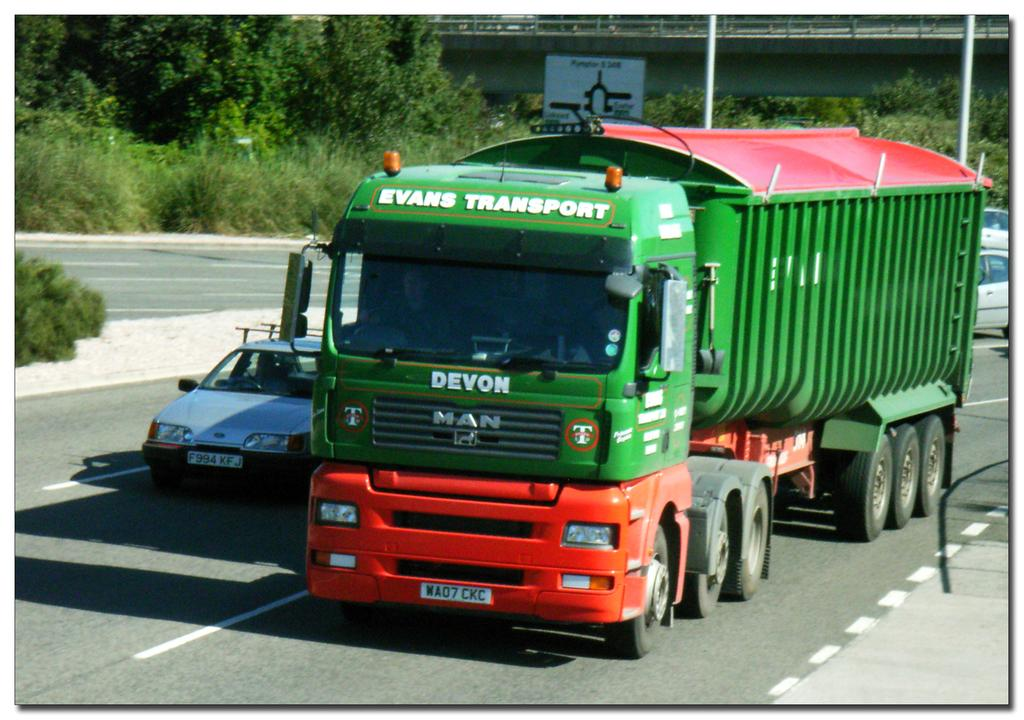What type of vegetation is on the left side of the image? There are trees on the left side of the image. What vehicles can be seen in the image? A car and a truck are visible in the image. What are the vehicles doing in the image? The car and truck are moving on the roads. What type of snails can be seen on the face of the truck driver in the image? There are no snails or faces of truck drivers visible in the image. What type of crime is being committed in the image? There is no crime being committed in the image; it simply shows a car and a truck moving on the roads. 